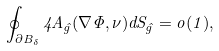Convert formula to latex. <formula><loc_0><loc_0><loc_500><loc_500>\oint _ { \partial B _ { \delta } } 4 A _ { \hat { g } } ( \nabla \Phi , \nu ) d S _ { \hat { g } } = o ( 1 ) ,</formula> 